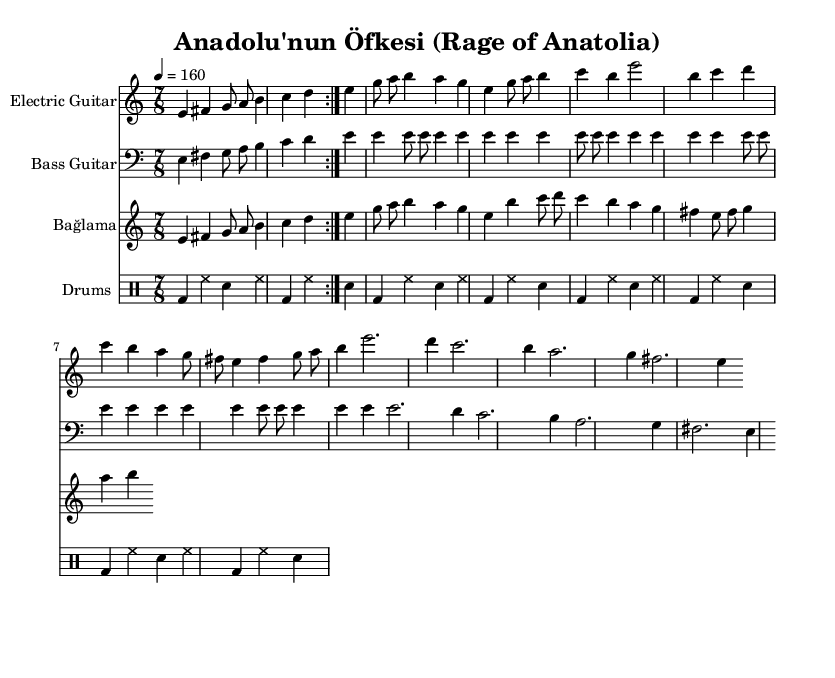What is the key signature of this music? The key signature is E Phrygian, as indicated at the beginning of the score, which relates to E minor but has a distinctive feel that contributes to the Middle Eastern melodies.
Answer: E Phrygian What is the time signature of this piece? The time signature is 7/8, which can be seen at the beginning of the score. This indicates that there are seven beats in a measure, giving it a unique rhythmic feel common in progressive metal and traditional Anatolian music.
Answer: 7/8 What is the tempo marking for this composition? The tempo marking is given as quarter note equals 160, which sets a fast pace for the piece, making it suitable for the energetic style of metal music.
Answer: 160 Which instrument has a simplified part in the arrangement? The Bağlama has a simplified part, as indicated by the label and its melodic line, which is less intricate compared to the electric guitar.
Answer: Bağlama How many times is the main riff repeated? The main riff is repeated four times, as specified by the notation in the electric guitar and bass guitar sections, signaling its importance within the composition.
Answer: 4 What is the primary characteristic of the tones in the main riff? The primary characteristic of the tones in the main riff is they are mostly ascending, creating an uplifting and powerful feel that is often found in metal music.
Answer: Ascending What type of rhythmic pattern do the drums follow throughout the piece? The drums follow a simple repetitive pattern, which complements the melodic lines and helps maintain the energetic drive typical in metal genre.
Answer: Simple repetitive pattern 